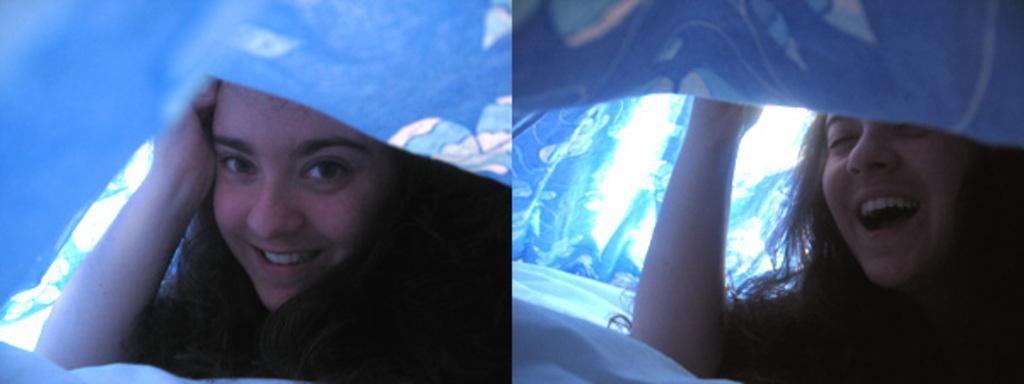In one or two sentences, can you explain what this image depicts? In this picture we can see a woman is under the blanket. She is smiling. 